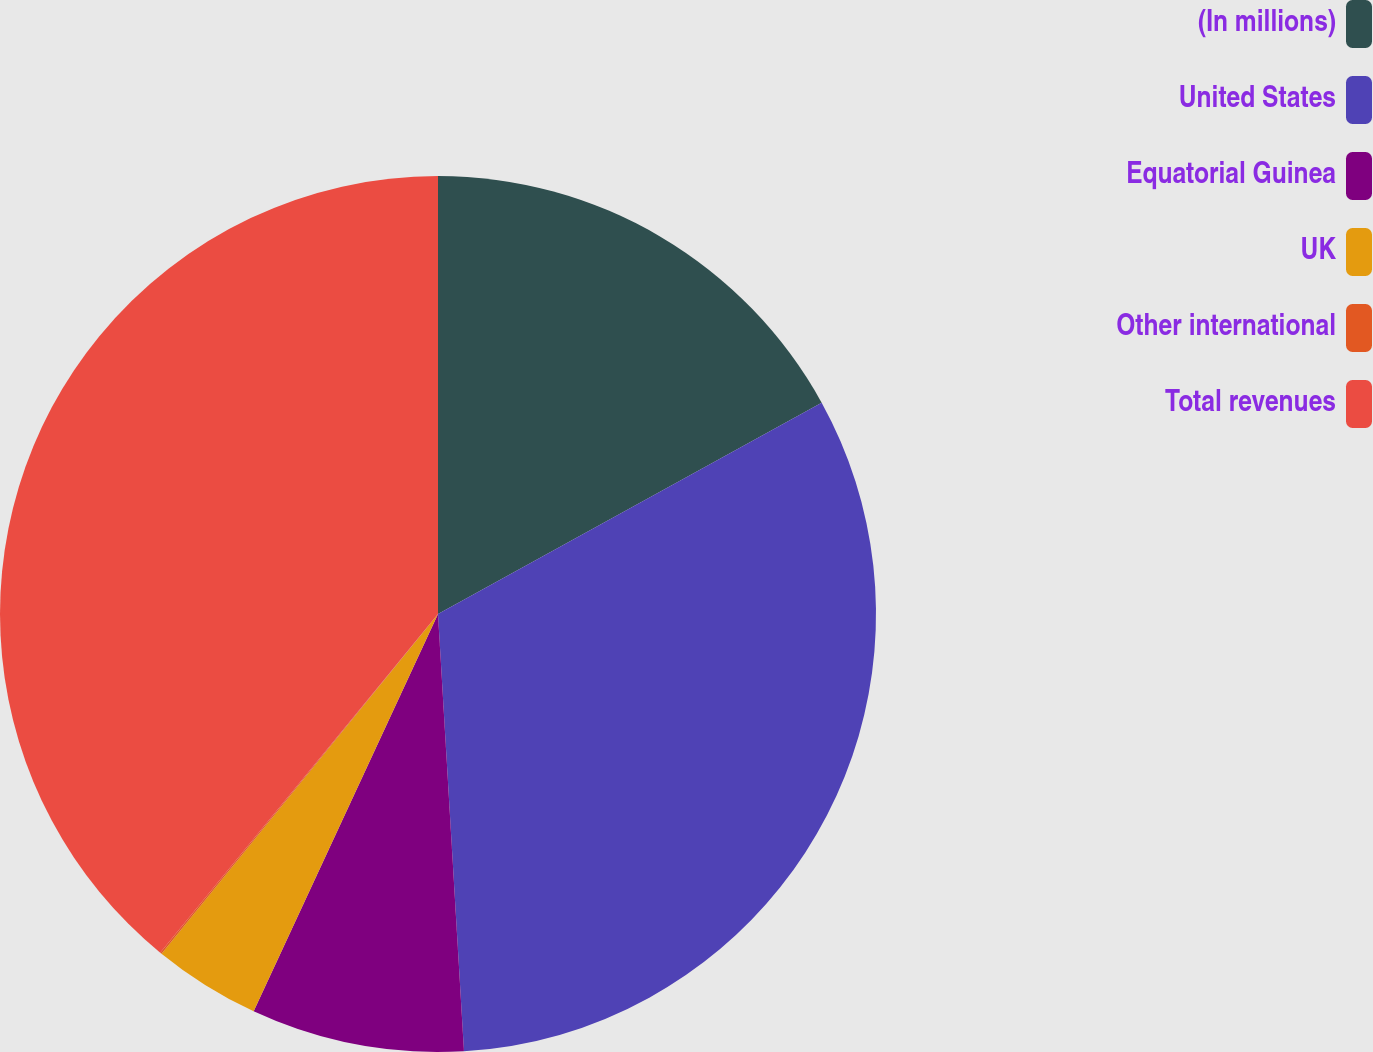Convert chart to OTSL. <chart><loc_0><loc_0><loc_500><loc_500><pie_chart><fcel>(In millions)<fcel>United States<fcel>Equatorial Guinea<fcel>UK<fcel>Other international<fcel>Total revenues<nl><fcel>16.99%<fcel>32.07%<fcel>7.86%<fcel>3.96%<fcel>0.06%<fcel>39.07%<nl></chart> 